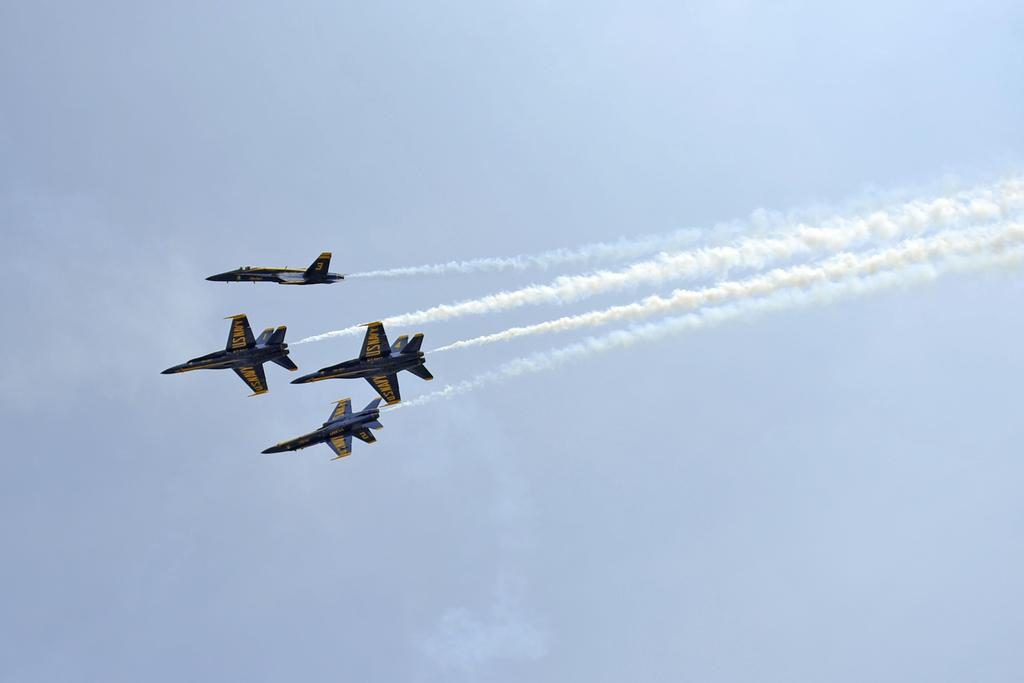What type of vehicles are in the image? There are jet planes in the image. Where are the jet planes located? The jet planes are in the air. What can be seen coming from the jet planes? There is smoke visible in the image. What type of mint is growing near the jet planes in the image? There is no mint present in the image; it features jet planes in the air with visible smoke. 